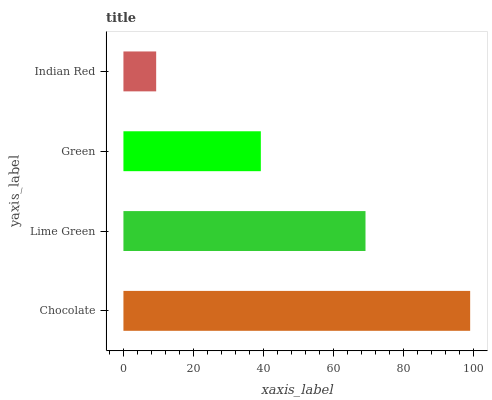Is Indian Red the minimum?
Answer yes or no. Yes. Is Chocolate the maximum?
Answer yes or no. Yes. Is Lime Green the minimum?
Answer yes or no. No. Is Lime Green the maximum?
Answer yes or no. No. Is Chocolate greater than Lime Green?
Answer yes or no. Yes. Is Lime Green less than Chocolate?
Answer yes or no. Yes. Is Lime Green greater than Chocolate?
Answer yes or no. No. Is Chocolate less than Lime Green?
Answer yes or no. No. Is Lime Green the high median?
Answer yes or no. Yes. Is Green the low median?
Answer yes or no. Yes. Is Green the high median?
Answer yes or no. No. Is Lime Green the low median?
Answer yes or no. No. 